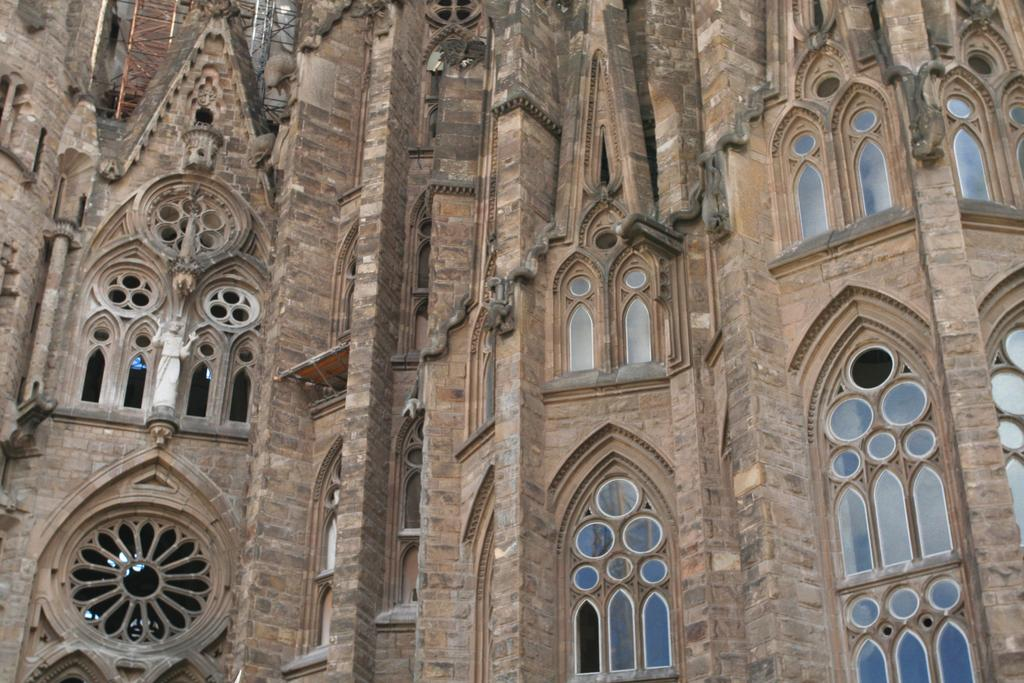What is the main subject of the image? The main subject of the image is a building. Can you describe the building in the image? The building has many windows. What type of foot is visible on the building in the image? There is no foot visible on the building in the image. What color is the dress worn by the building in the image? Buildings do not wear dresses, so this question cannot be answered. 